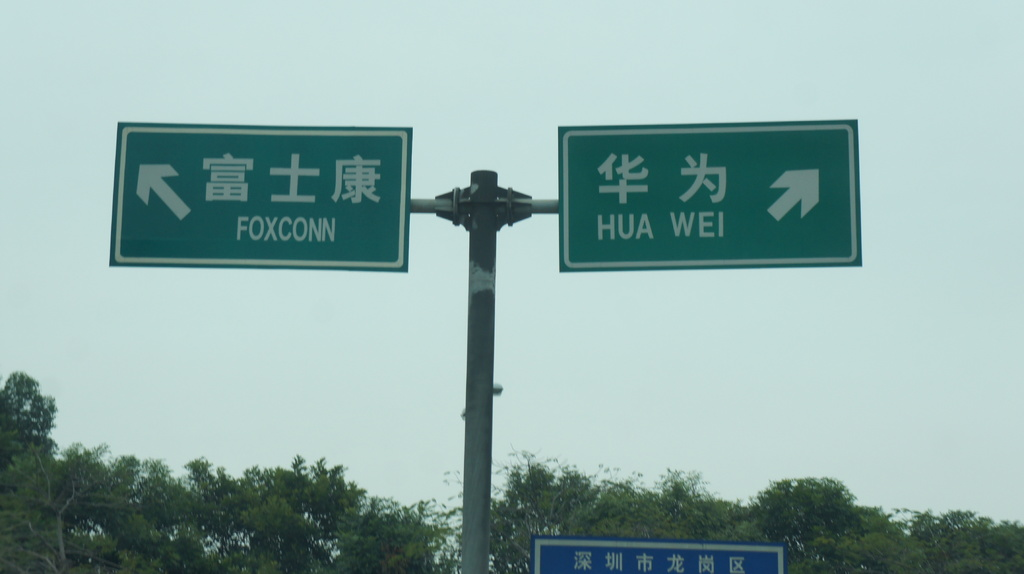Can you tell me what Foxconn and Huawei are known for in the tech industry? Foxconn is renowned for its extensive manufacturing of electronics, including components and products for major global tech companies. Huawei is well-known for its telecommunications equipment and consumer electronics, particularly smartphones. 